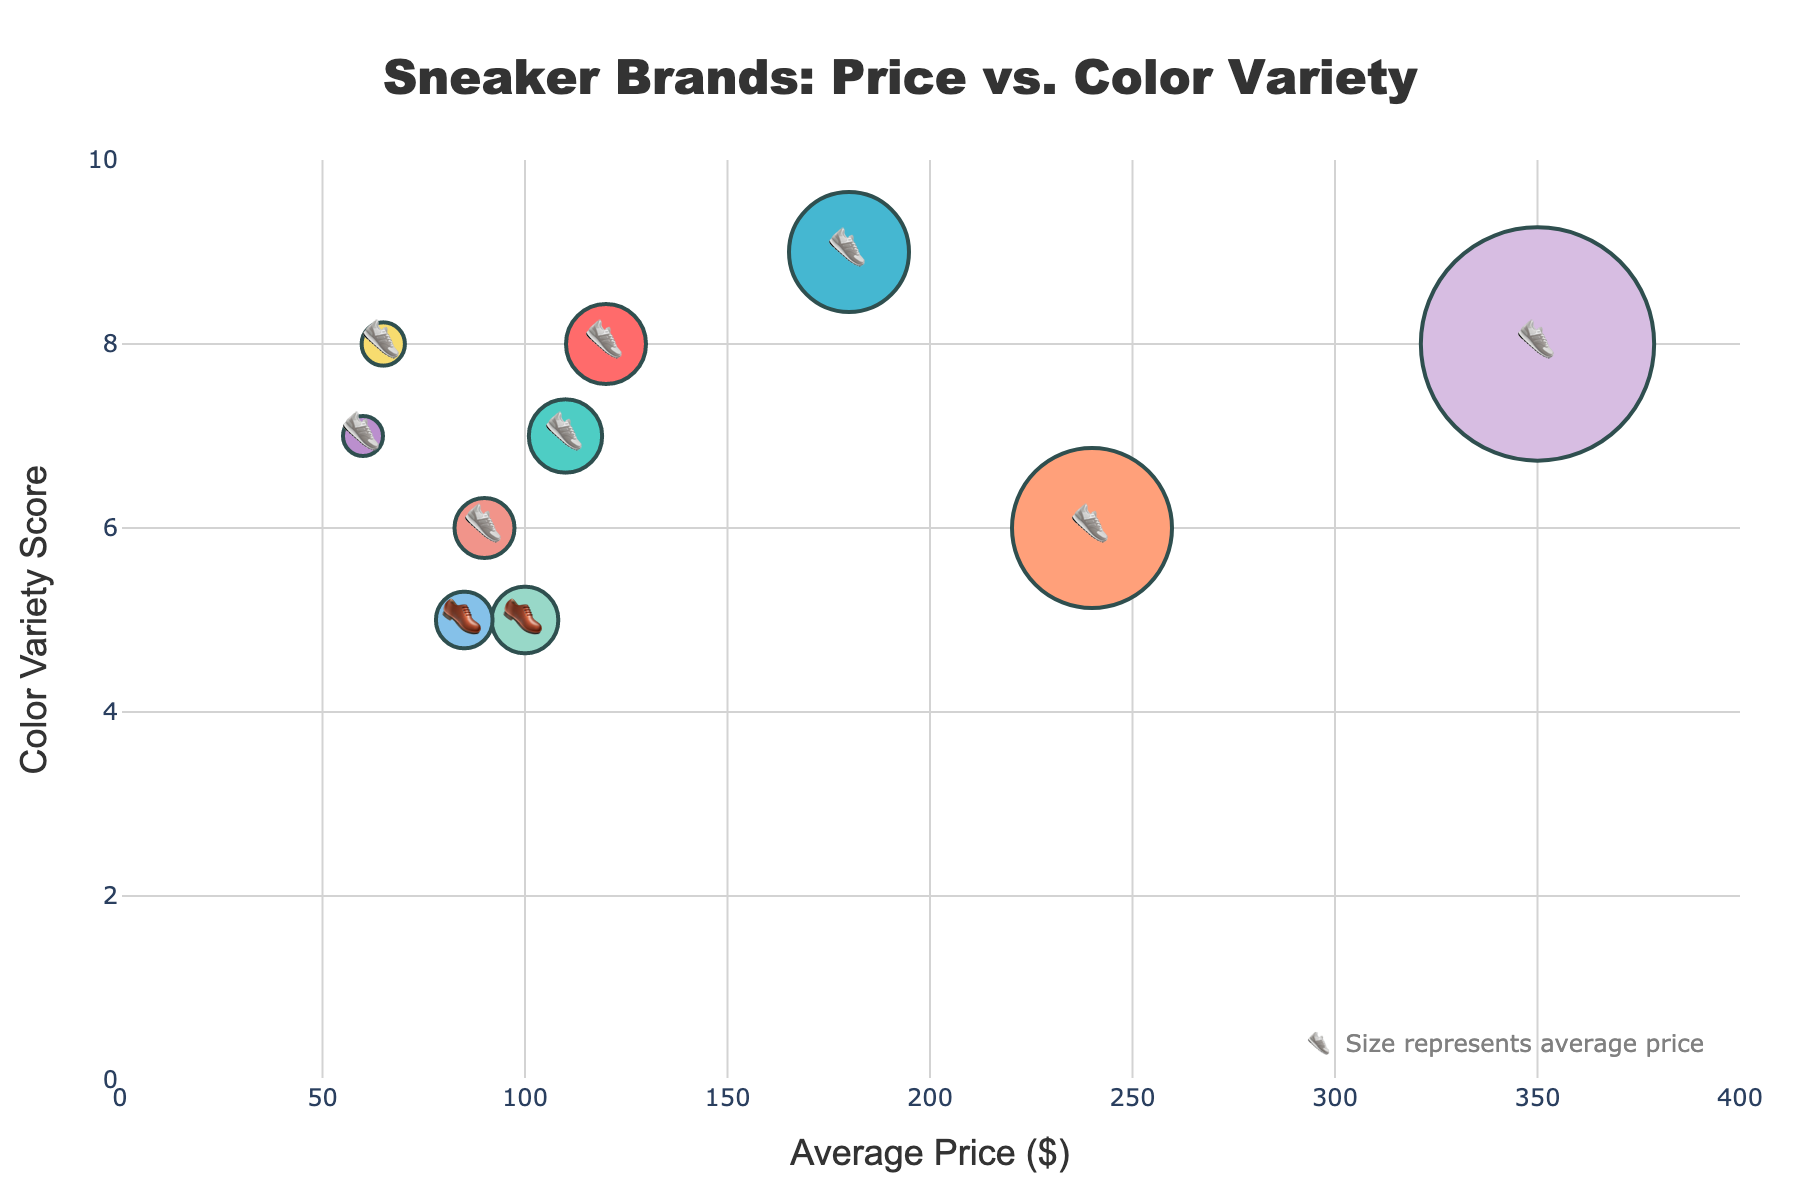Which brand has the highest average price? The brand with the largest shoe emoji size would have the highest average price. By looking at the figure, Off-White has the biggest shoe, indicating it has the highest average price.
Answer: Off-White Which brand offers the most color variety? The brand with the highest position on the y-axis has the most color variety. The highest y-value is associated with Jordan.
Answer: Jordan How does Adidas compare to Nike in terms of average price and color variety? Locate the positions of Adidas and Nike on the figure. Nike’s shoe emoji is slightly larger and positioned a bit higher than Adidas, indicating Nike has a higher average price and more color variety.
Answer: Nike has a higher price and more color variety What is the color variety score of Yeezy in relation to Reebok? Look at the y-axis positions of both Yeezy and Reebok. Yeezy is positioned higher than Reebok, indicating a higher color variety score. Yeezy's color variety score is 6, and Reebok's is 5.
Answer: Yeezy's score is higher by 1 Which brands have an average price under $100? Identify the shoe emojis corresponding to data points below the $100 mark on the x-axis. Vans, Converse, Puma, and Reebok meet this criterion.
Answer: Vans, Converse, Puma, Reebok Which brand combines a high color variety with a relatively low price? Look for a brand positioned high on the y-axis (indicating high color variety) and to the left of the $100 mark on the x-axis (indicating a lower price). Vans, with a color variety score of 8 and an average price of $65, fits this description.
Answer: Vans Based on the figure, how much more expensive is Jordan compared to Adidas? Note the positions along the x-axis for both Jordan and Adidas. Jordan is at $180 and Adidas at $110. The difference is $180 - $110 = $70.
Answer: $70 Which two brands have the same highest color variety score? Both Jordan and Off-White have the same highest y-position, each with a color variety score of 9 and 8 respectively.
Answer: Jordan and Off-White How is the average price of New Balance relative to Puma? Check the x-axis positions of New Balance and Puma. New Balance is at $100 while Puma is at $90, indicating New Balance is $10 more expensive.
Answer: New Balance is $10 more expensive 